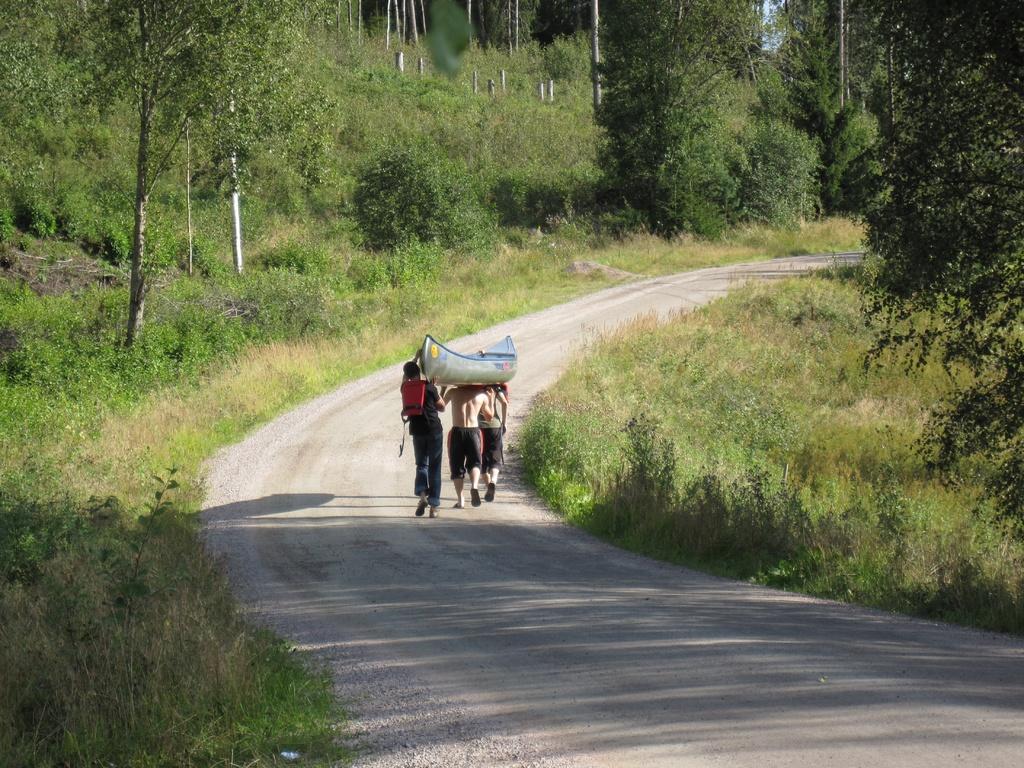Please provide a concise description of this image. In this picture there is a road in the center. On the road, there are three men moving towards the north and holding the boat on their shoulders. On either side of the road, there are plants and trees. 